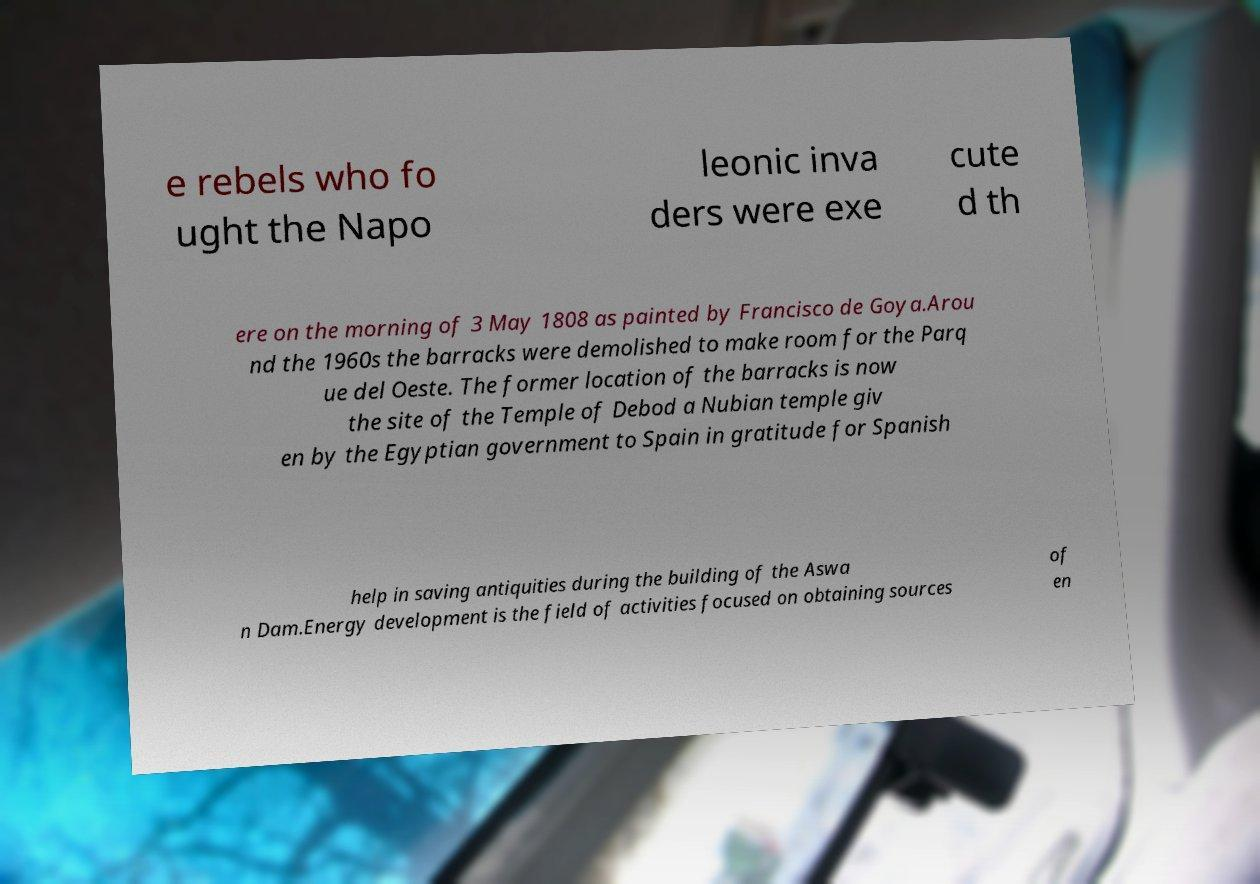I need the written content from this picture converted into text. Can you do that? e rebels who fo ught the Napo leonic inva ders were exe cute d th ere on the morning of 3 May 1808 as painted by Francisco de Goya.Arou nd the 1960s the barracks were demolished to make room for the Parq ue del Oeste. The former location of the barracks is now the site of the Temple of Debod a Nubian temple giv en by the Egyptian government to Spain in gratitude for Spanish help in saving antiquities during the building of the Aswa n Dam.Energy development is the field of activities focused on obtaining sources of en 